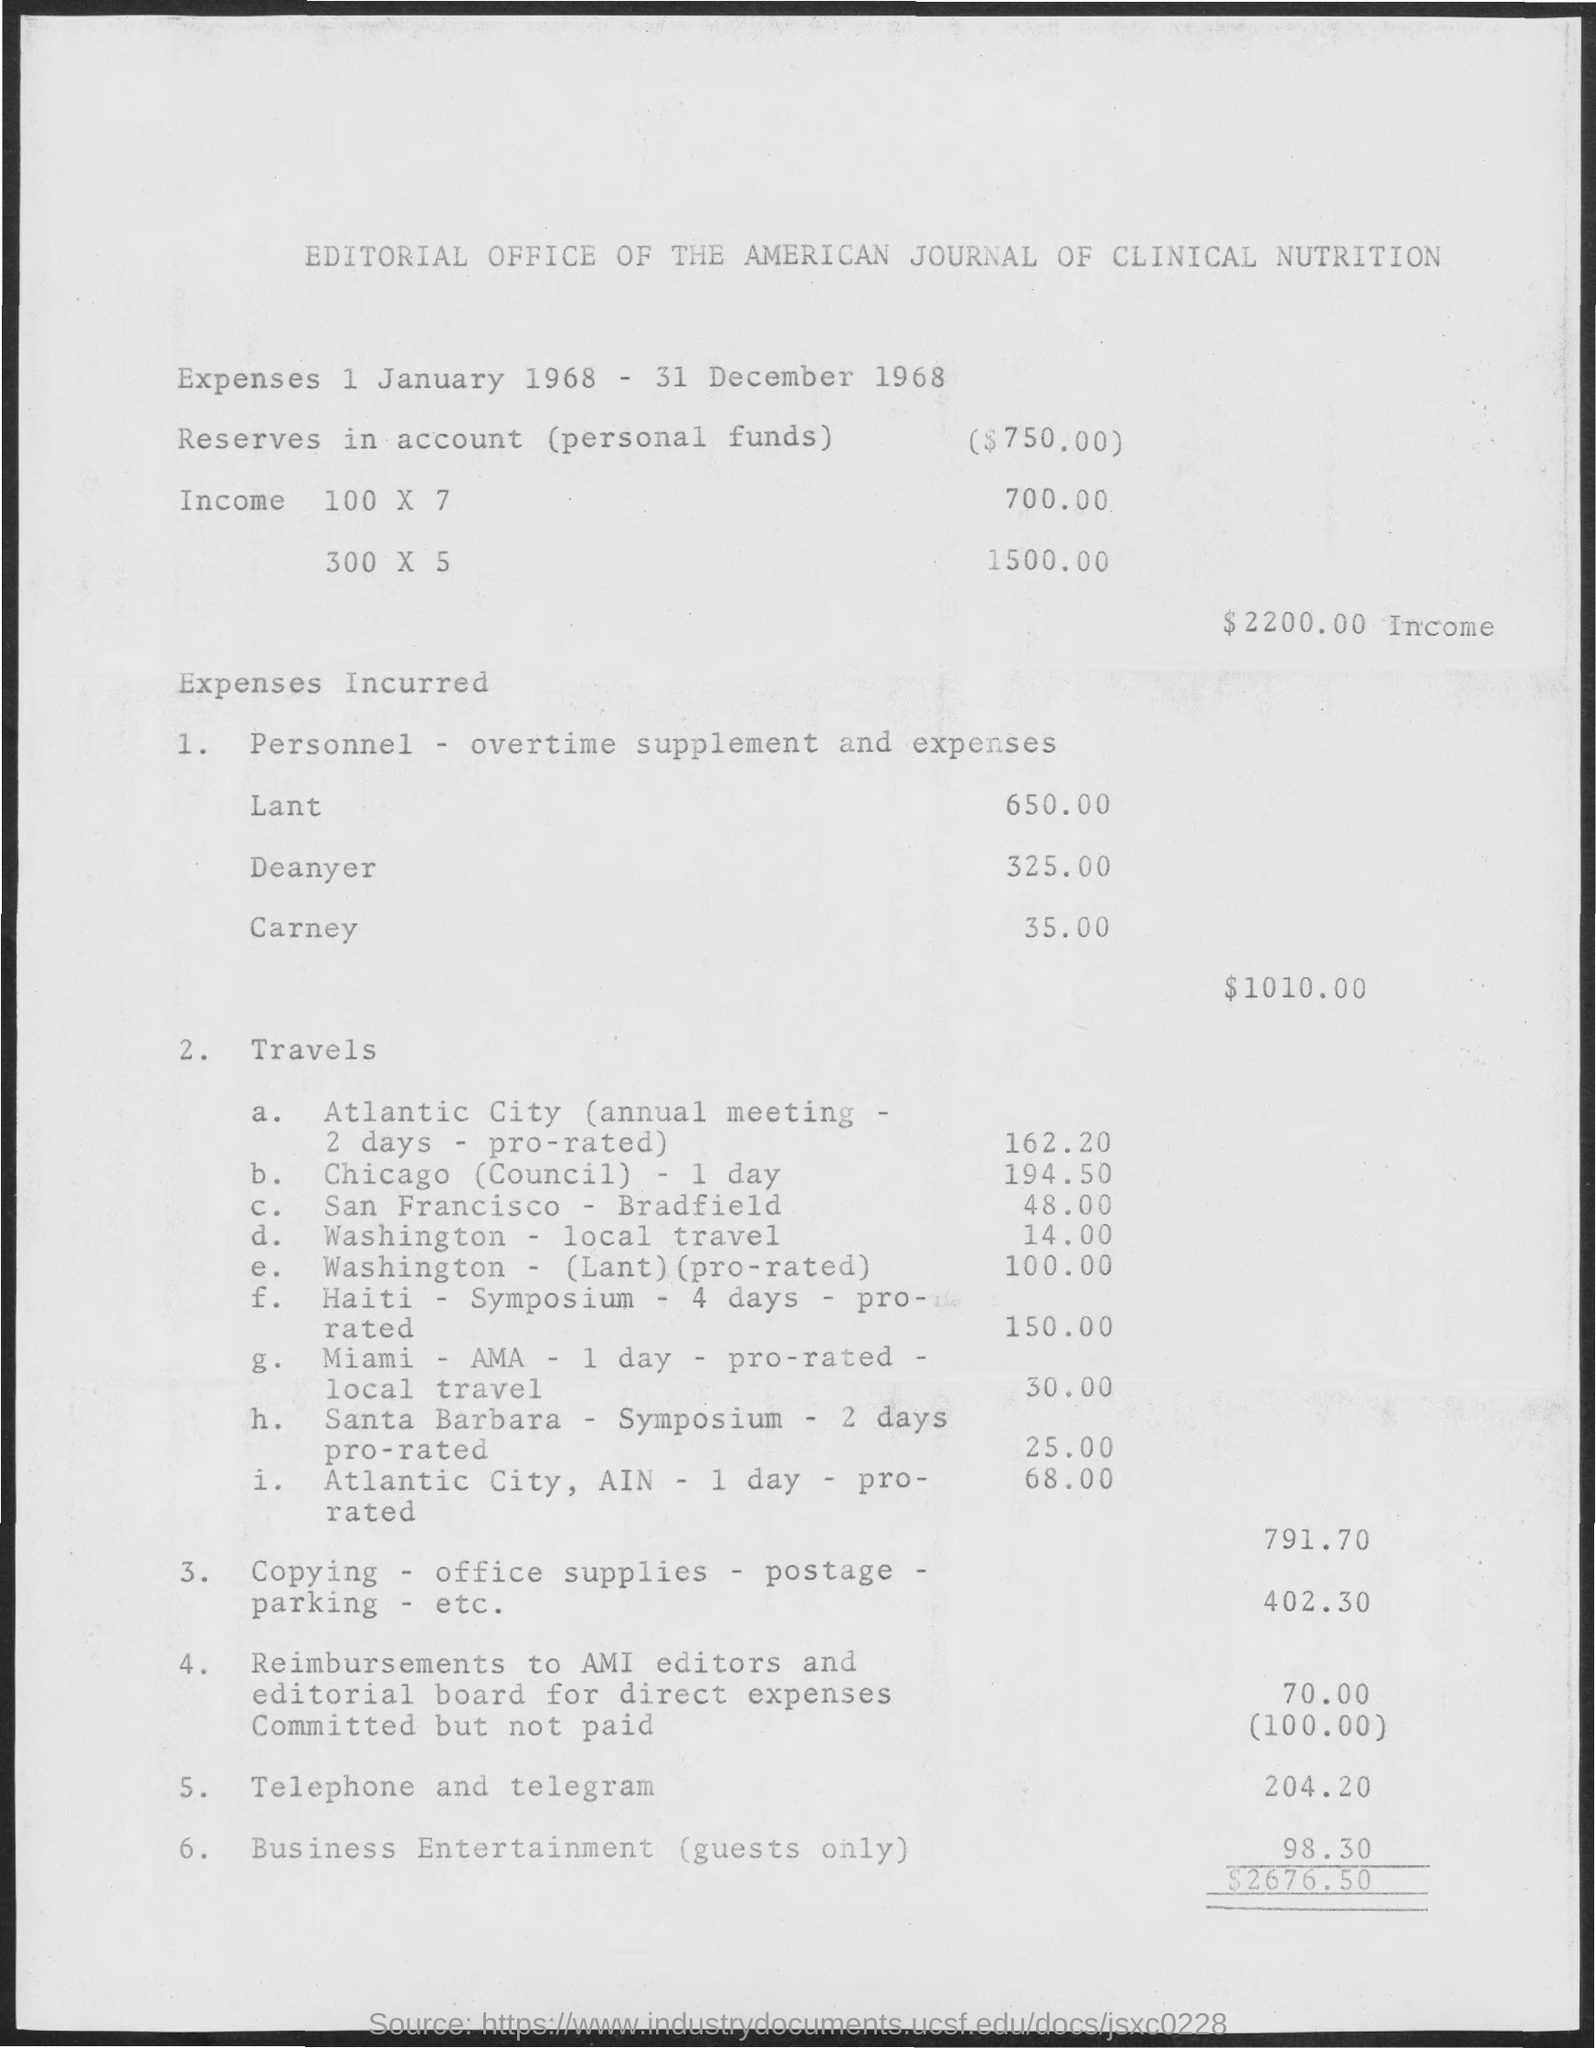Specify some key components in this picture. A total of $1,010.00 was incurred in personnel expenses. The expenses lasted from 1 January 1968 to 31 December 1968. 